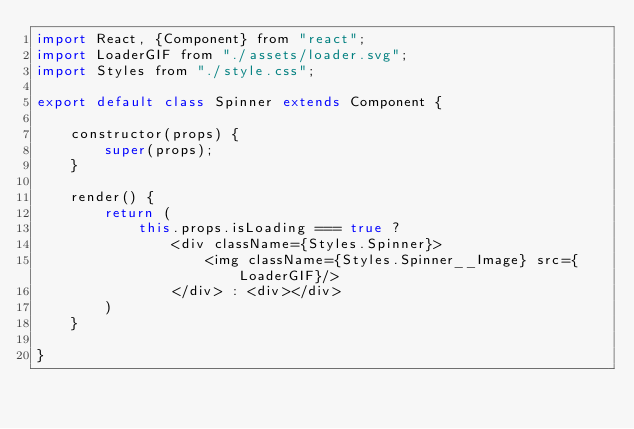<code> <loc_0><loc_0><loc_500><loc_500><_JavaScript_>import React, {Component} from "react";
import LoaderGIF from "./assets/loader.svg";
import Styles from "./style.css";

export default class Spinner extends Component {

    constructor(props) {
        super(props);
    }

    render() {
        return (
            this.props.isLoading === true ?
                <div className={Styles.Spinner}>
                    <img className={Styles.Spinner__Image} src={LoaderGIF}/>
                </div> : <div></div>
        )
    }

}</code> 